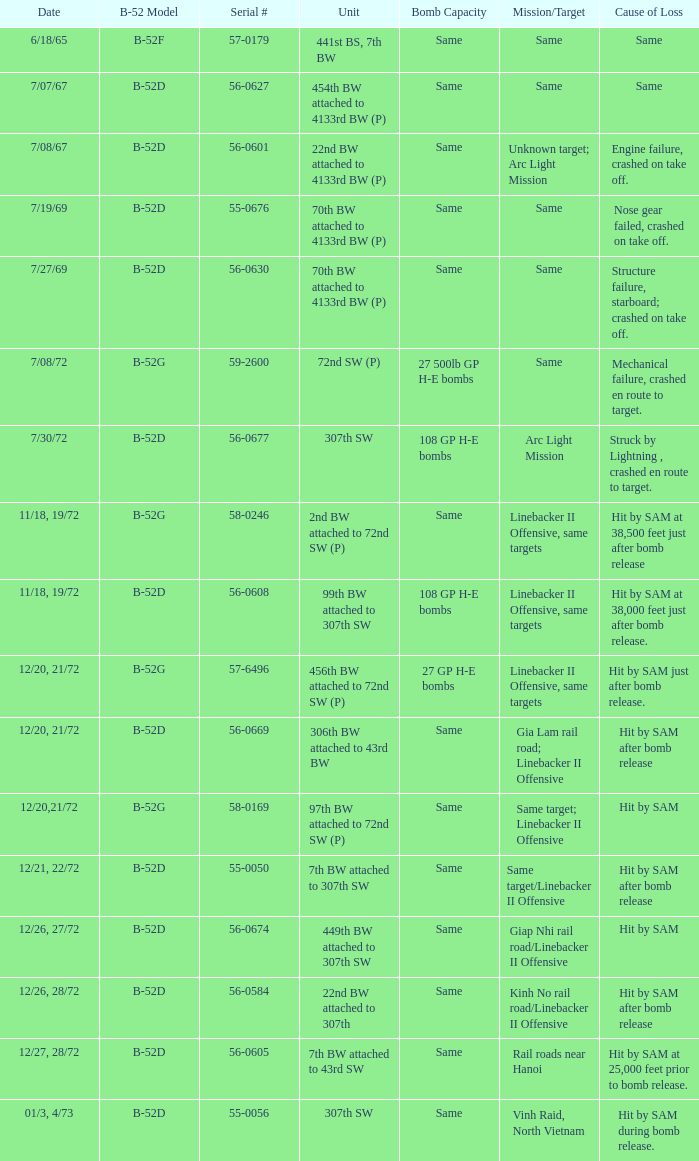When  same target; linebacker ii offensive is the same target what is the unit? 97th BW attached to 72nd SW (P). 